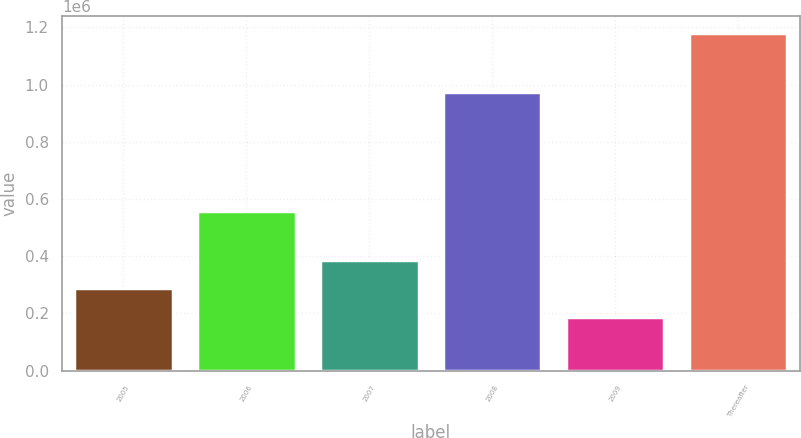<chart> <loc_0><loc_0><loc_500><loc_500><bar_chart><fcel>2005<fcel>2006<fcel>2007<fcel>2008<fcel>2009<fcel>Thereafter<nl><fcel>287413<fcel>557123<fcel>386547<fcel>974758<fcel>188278<fcel>1.17962e+06<nl></chart> 